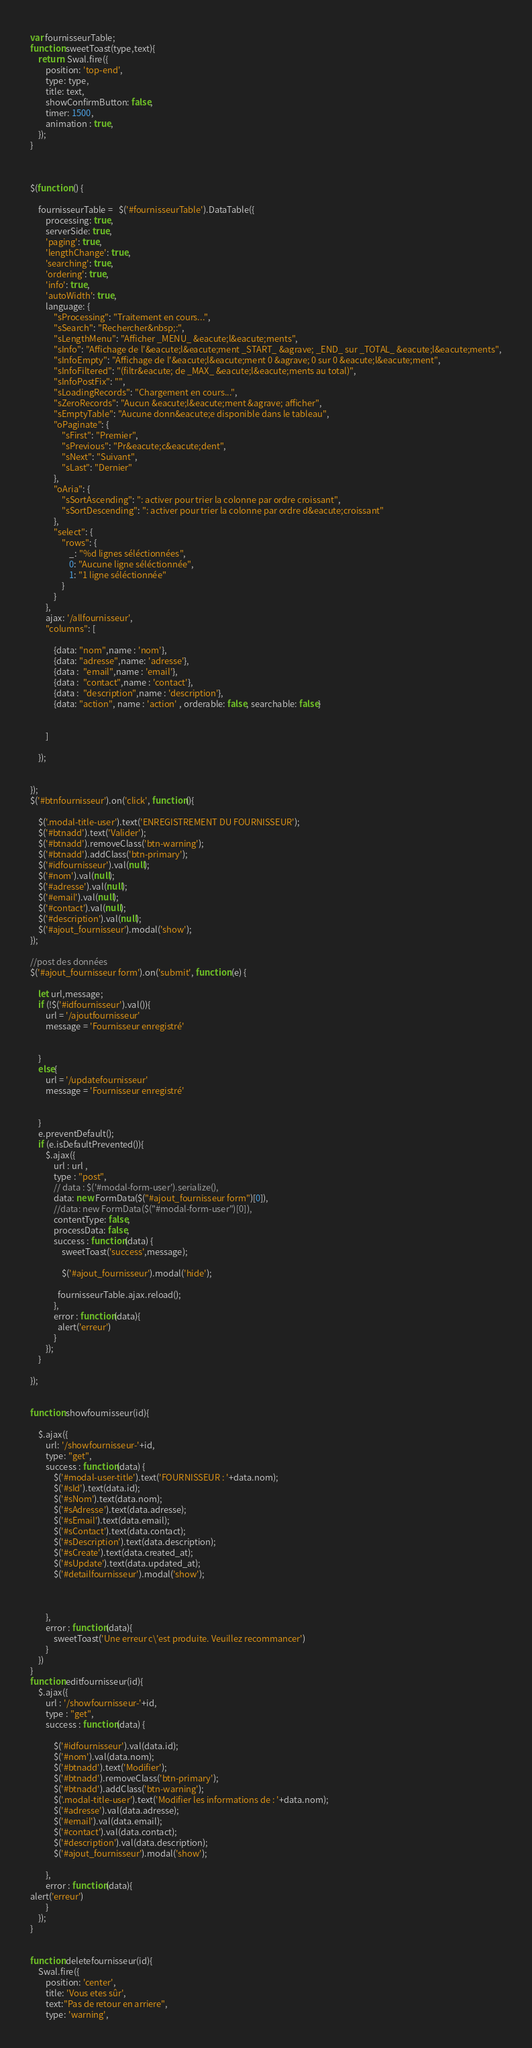<code> <loc_0><loc_0><loc_500><loc_500><_JavaScript_>

var fournisseurTable;
function sweetToast(type,text){
    return  Swal.fire({
        position: 'top-end',
        type: type,
        title: text,
        showConfirmButton: false,
        timer: 1500,
        animation : true,
    });
}



$(function () {

    fournisseurTable =   $('#fournisseurTable').DataTable({
        processing: true,
        serverSide: true,
        'paging': true,
        'lengthChange': true,
        'searching': true,
        'ordering': true,
        'info': true,
        'autoWidth': true,
        language: {
            "sProcessing": "Traitement en cours...",
            "sSearch": "Rechercher&nbsp;:",
            "sLengthMenu": "Afficher _MENU_ &eacute;l&eacute;ments",
            "sInfo": "Affichage de l'&eacute;l&eacute;ment _START_ &agrave; _END_ sur _TOTAL_ &eacute;l&eacute;ments",
            "sInfoEmpty": "Affichage de l'&eacute;l&eacute;ment 0 &agrave; 0 sur 0 &eacute;l&eacute;ment",
            "sInfoFiltered": "(filtr&eacute; de _MAX_ &eacute;l&eacute;ments au total)",
            "sInfoPostFix": "",
            "sLoadingRecords": "Chargement en cours...",
            "sZeroRecords": "Aucun &eacute;l&eacute;ment &agrave; afficher",
            "sEmptyTable": "Aucune donn&eacute;e disponible dans le tableau",
            "oPaginate": {
                "sFirst": "Premier",
                "sPrevious": "Pr&eacute;c&eacute;dent",
                "sNext": "Suivant",
                "sLast": "Dernier"
            },
            "oAria": {
                "sSortAscending": ": activer pour trier la colonne par ordre croissant",
                "sSortDescending": ": activer pour trier la colonne par ordre d&eacute;croissant"
            },
            "select": {
                "rows": {
                    _: "%d lignes séléctionnées",
                    0: "Aucune ligne séléctionnée",
                    1: "1 ligne séléctionnée"
                }
            }
        },
        ajax: '/allfournisseur',
        "columns": [

            {data: "nom",name : 'nom'},
            {data: "adresse",name: 'adresse'},
            {data :  "email",name : 'email'},
            {data :  "contact",name : 'contact'},
            {data :  "description",name : 'description'},
            {data: "action", name : 'action' , orderable: false, searchable: false}


        ]

    });


});
$('#btnfournisseur').on('click', function(){

    $('.modal-title-user').text('ENREGISTREMENT DU FOURNISSEUR');
    $('#btnadd').text('Valider');
    $('#btnadd').removeClass('btn-warning');
    $('#btnadd').addClass('btn-primary');
    $('#idfournisseur').val(null);
    $('#nom').val(null);
    $('#adresse').val(null);
    $('#email').val(null);
    $('#contact').val(null);
    $('#description').val(null);
    $('#ajout_fournisseur').modal('show');
});

//post des données
$('#ajout_fournisseur form').on('submit', function (e) {

    let url,message;
    if (!$('#idfournisseur').val()){
        url = '/ajoutfournisseur'
        message = 'Fournisseur enregistré'


    }
    else{
        url = '/updatefournisseur'
        message = 'Fournisseur enregistré'


    }
    e.preventDefault();
    if (e.isDefaultPrevented()){
        $.ajax({
            url : url ,
            type : "post",
            // data : $('#modal-form-user').serialize(),
            data: new FormData($("#ajout_fournisseur form")[0]),
            //data: new FormData($("#modal-form-user")[0]),
            contentType: false,
            processData: false,
            success : function(data) {
                sweetToast('success',message);

                $('#ajout_fournisseur').modal('hide');

              fournisseurTable.ajax.reload();
            },
            error : function(data){
              alert('erreur')
            }
        });
    }

});


function showfournisseur(id){

    $.ajax({
        url: '/showfournisseur-'+id,
        type: "get",
        success : function(data) {
            $('#modal-user-title').text('FOURNISSEUR : '+data.nom);
            $('#sId').text(data.id);
            $('#sNom').text(data.nom);
            $('#sAdresse').text(data.adresse);
            $('#sEmail').text(data.email);
            $('#sContact').text(data.contact);
            $('#sDescription').text(data.description);
            $('#sCreate').text(data.created_at);
            $('#sUpdate').text(data.updated_at);
            $('#detailfournisseur').modal('show');



        },
        error : function(data){
            sweetToast('Une erreur c\'est produite. Veuillez recommancer')
        }
    })
}
function editfournisseur(id){
    $.ajax({
        url : '/showfournisseur-'+id,
        type : "get",
        success : function(data) {

            $('#idfournisseur').val(data.id);
            $('#nom').val(data.nom);
            $('#btnadd').text('Modifier');
            $('#btnadd').removeClass('btn-primary');
            $('#btnadd').addClass('btn-warning');
            $('.modal-title-user').text('Modifier les informations de : '+data.nom);
            $('#adresse').val(data.adresse);
            $('#email').val(data.email);
            $('#contact').val(data.contact);
            $('#description').val(data.description);
            $('#ajout_fournisseur').modal('show');

        },
        error : function(data){
alert('erreur')
        }
    });
}


function deletefournisseur(id){
    Swal.fire({
        position: 'center',
        title: 'Vous etes sûr',
        text:"Pas de retour en arriere",
        type: 'warning',</code> 